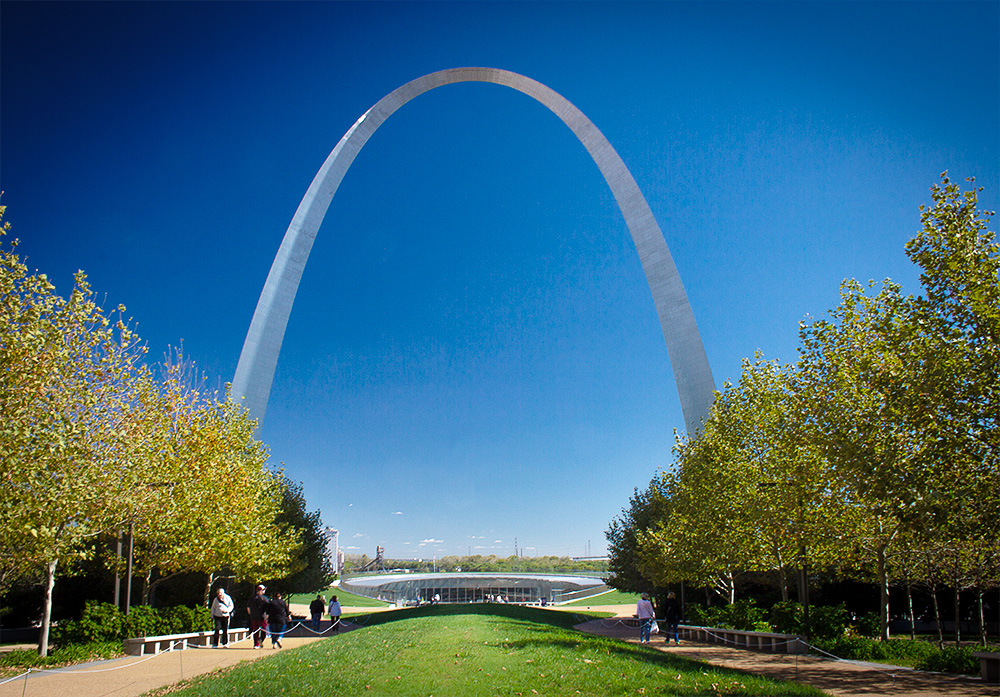Can you describe the main features of this image for me? The image showcases the iconic Gateway Arch in St. Louis, Missouri, soaring impressively at 630 feet, making it the tallest arch in the world. Its stainless steel surface glistens under a clear blue sky, adding a sleek and modern touch to the monumental structure. The arch is perfectly framed and stands majestically at the center, enhancing its grandiosity. In the foreground, a scenic park filled with lush green trees stretches out, providing a natural contrast to the arch. People can be seen leisurely walking and enjoying the serene environment, adding a dynamic and lively aspect to the scene. The photo captures the elegance and prominence of the arch from a vantage point that vividly emphasizes its towering height and architectural splendor. 